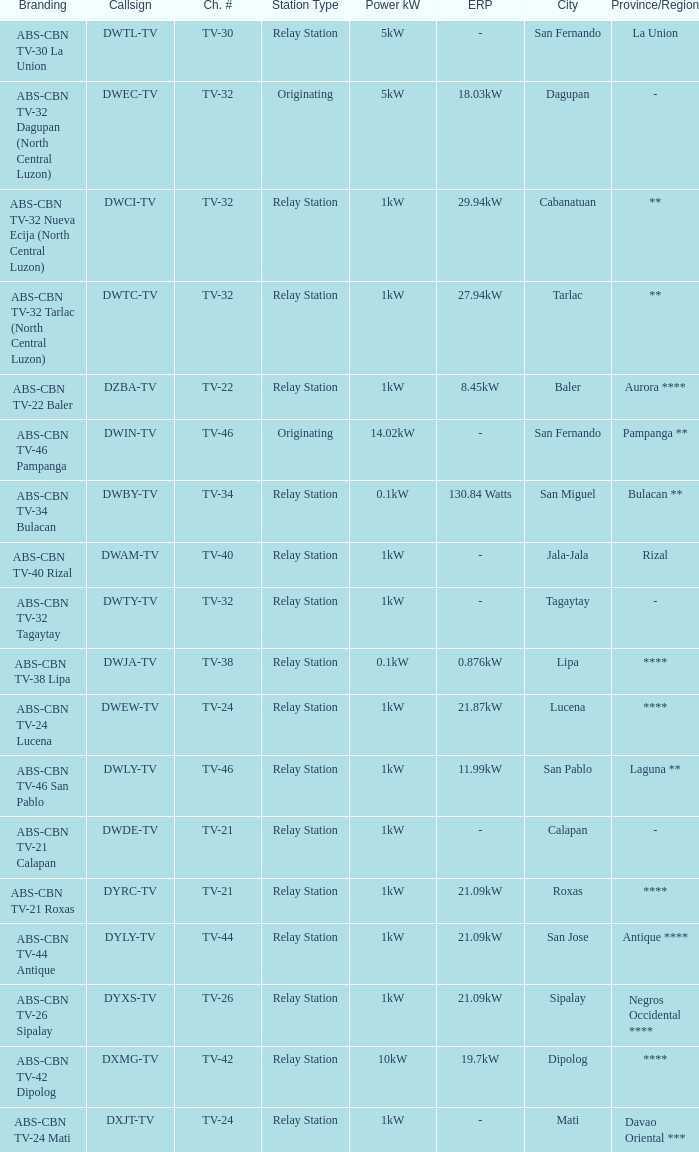The location (transmitter site) San Fernando, Pampanga ** has what Power kW (ERP)? 14.02kW. 